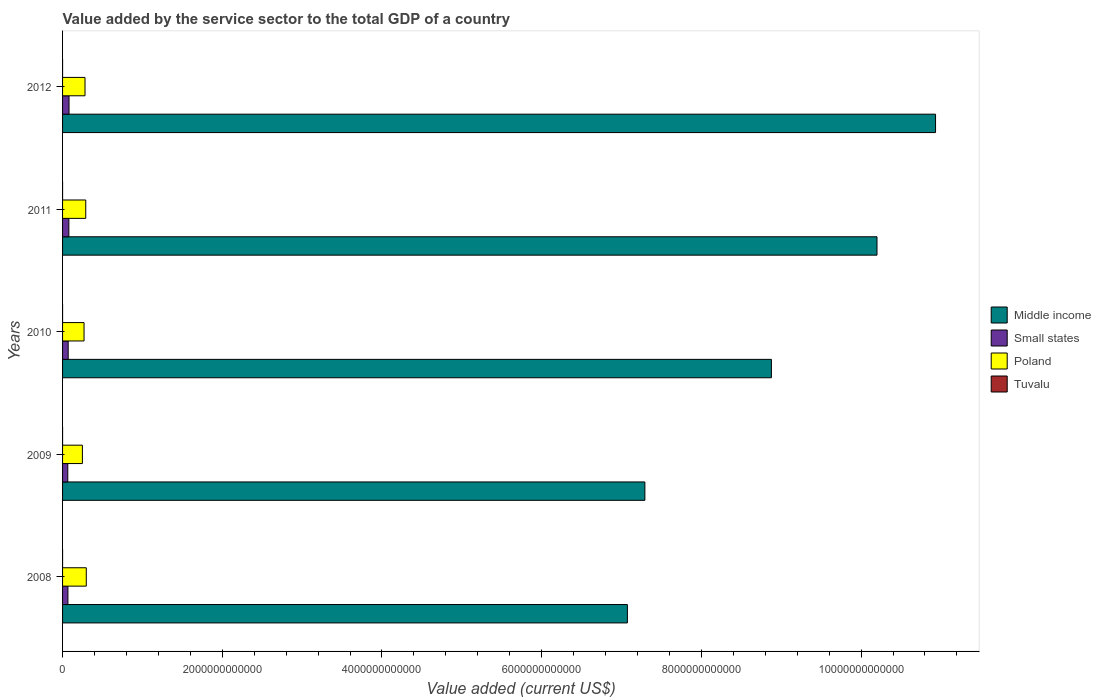How many groups of bars are there?
Your answer should be very brief. 5. Are the number of bars on each tick of the Y-axis equal?
Your answer should be very brief. Yes. How many bars are there on the 4th tick from the bottom?
Offer a terse response. 4. What is the value added by the service sector to the total GDP in Small states in 2012?
Your answer should be very brief. 8.09e+1. Across all years, what is the maximum value added by the service sector to the total GDP in Small states?
Offer a very short reply. 8.09e+1. Across all years, what is the minimum value added by the service sector to the total GDP in Middle income?
Offer a very short reply. 7.07e+12. In which year was the value added by the service sector to the total GDP in Middle income maximum?
Your answer should be very brief. 2012. What is the total value added by the service sector to the total GDP in Tuvalu in the graph?
Provide a short and direct response. 1.01e+08. What is the difference between the value added by the service sector to the total GDP in Tuvalu in 2009 and that in 2012?
Ensure brevity in your answer.  -1.04e+07. What is the difference between the value added by the service sector to the total GDP in Poland in 2010 and the value added by the service sector to the total GDP in Tuvalu in 2011?
Your answer should be very brief. 2.69e+11. What is the average value added by the service sector to the total GDP in Poland per year?
Make the answer very short. 2.77e+11. In the year 2008, what is the difference between the value added by the service sector to the total GDP in Tuvalu and value added by the service sector to the total GDP in Poland?
Your answer should be very brief. -2.97e+11. What is the ratio of the value added by the service sector to the total GDP in Small states in 2011 to that in 2012?
Make the answer very short. 0.97. Is the difference between the value added by the service sector to the total GDP in Tuvalu in 2008 and 2012 greater than the difference between the value added by the service sector to the total GDP in Poland in 2008 and 2012?
Your answer should be compact. No. What is the difference between the highest and the second highest value added by the service sector to the total GDP in Middle income?
Ensure brevity in your answer.  7.33e+11. What is the difference between the highest and the lowest value added by the service sector to the total GDP in Middle income?
Your answer should be compact. 3.86e+12. In how many years, is the value added by the service sector to the total GDP in Tuvalu greater than the average value added by the service sector to the total GDP in Tuvalu taken over all years?
Offer a very short reply. 2. Is it the case that in every year, the sum of the value added by the service sector to the total GDP in Middle income and value added by the service sector to the total GDP in Tuvalu is greater than the sum of value added by the service sector to the total GDP in Poland and value added by the service sector to the total GDP in Small states?
Keep it short and to the point. Yes. What does the 2nd bar from the bottom in 2008 represents?
Offer a terse response. Small states. Are all the bars in the graph horizontal?
Make the answer very short. Yes. What is the difference between two consecutive major ticks on the X-axis?
Offer a very short reply. 2.00e+12. Does the graph contain any zero values?
Provide a short and direct response. No. Where does the legend appear in the graph?
Your response must be concise. Center right. How are the legend labels stacked?
Make the answer very short. Vertical. What is the title of the graph?
Provide a short and direct response. Value added by the service sector to the total GDP of a country. What is the label or title of the X-axis?
Offer a very short reply. Value added (current US$). What is the label or title of the Y-axis?
Give a very brief answer. Years. What is the Value added (current US$) of Middle income in 2008?
Provide a succinct answer. 7.07e+12. What is the Value added (current US$) of Small states in 2008?
Your answer should be compact. 6.71e+1. What is the Value added (current US$) of Poland in 2008?
Make the answer very short. 2.97e+11. What is the Value added (current US$) in Tuvalu in 2008?
Provide a succinct answer. 1.70e+07. What is the Value added (current US$) in Middle income in 2009?
Provide a short and direct response. 7.29e+12. What is the Value added (current US$) of Small states in 2009?
Your answer should be compact. 6.54e+1. What is the Value added (current US$) in Poland in 2009?
Offer a very short reply. 2.48e+11. What is the Value added (current US$) of Tuvalu in 2009?
Your answer should be compact. 1.53e+07. What is the Value added (current US$) in Middle income in 2010?
Your response must be concise. 8.88e+12. What is the Value added (current US$) in Small states in 2010?
Ensure brevity in your answer.  7.04e+1. What is the Value added (current US$) in Poland in 2010?
Offer a very short reply. 2.69e+11. What is the Value added (current US$) in Tuvalu in 2010?
Provide a succinct answer. 1.94e+07. What is the Value added (current US$) in Middle income in 2011?
Your answer should be compact. 1.02e+13. What is the Value added (current US$) in Small states in 2011?
Your response must be concise. 7.88e+1. What is the Value added (current US$) of Poland in 2011?
Provide a short and direct response. 2.90e+11. What is the Value added (current US$) in Tuvalu in 2011?
Make the answer very short. 2.31e+07. What is the Value added (current US$) of Middle income in 2012?
Offer a very short reply. 1.09e+13. What is the Value added (current US$) of Small states in 2012?
Your answer should be very brief. 8.09e+1. What is the Value added (current US$) of Poland in 2012?
Your answer should be compact. 2.81e+11. What is the Value added (current US$) of Tuvalu in 2012?
Provide a succinct answer. 2.57e+07. Across all years, what is the maximum Value added (current US$) of Middle income?
Give a very brief answer. 1.09e+13. Across all years, what is the maximum Value added (current US$) of Small states?
Provide a succinct answer. 8.09e+1. Across all years, what is the maximum Value added (current US$) of Poland?
Offer a very short reply. 2.97e+11. Across all years, what is the maximum Value added (current US$) of Tuvalu?
Provide a short and direct response. 2.57e+07. Across all years, what is the minimum Value added (current US$) in Middle income?
Offer a very short reply. 7.07e+12. Across all years, what is the minimum Value added (current US$) in Small states?
Offer a terse response. 6.54e+1. Across all years, what is the minimum Value added (current US$) of Poland?
Make the answer very short. 2.48e+11. Across all years, what is the minimum Value added (current US$) of Tuvalu?
Offer a very short reply. 1.53e+07. What is the total Value added (current US$) of Middle income in the graph?
Your answer should be compact. 4.44e+13. What is the total Value added (current US$) of Small states in the graph?
Your response must be concise. 3.63e+11. What is the total Value added (current US$) of Poland in the graph?
Your answer should be compact. 1.39e+12. What is the total Value added (current US$) of Tuvalu in the graph?
Your answer should be compact. 1.01e+08. What is the difference between the Value added (current US$) in Middle income in 2008 and that in 2009?
Your answer should be compact. -2.19e+11. What is the difference between the Value added (current US$) in Small states in 2008 and that in 2009?
Offer a very short reply. 1.69e+09. What is the difference between the Value added (current US$) of Poland in 2008 and that in 2009?
Provide a short and direct response. 4.88e+1. What is the difference between the Value added (current US$) of Tuvalu in 2008 and that in 2009?
Offer a terse response. 1.70e+06. What is the difference between the Value added (current US$) of Middle income in 2008 and that in 2010?
Ensure brevity in your answer.  -1.80e+12. What is the difference between the Value added (current US$) in Small states in 2008 and that in 2010?
Your response must be concise. -3.32e+09. What is the difference between the Value added (current US$) of Poland in 2008 and that in 2010?
Provide a short and direct response. 2.80e+1. What is the difference between the Value added (current US$) in Tuvalu in 2008 and that in 2010?
Your response must be concise. -2.34e+06. What is the difference between the Value added (current US$) of Middle income in 2008 and that in 2011?
Provide a short and direct response. -3.13e+12. What is the difference between the Value added (current US$) in Small states in 2008 and that in 2011?
Keep it short and to the point. -1.17e+1. What is the difference between the Value added (current US$) in Poland in 2008 and that in 2011?
Give a very brief answer. 6.62e+09. What is the difference between the Value added (current US$) of Tuvalu in 2008 and that in 2011?
Offer a terse response. -6.05e+06. What is the difference between the Value added (current US$) in Middle income in 2008 and that in 2012?
Your answer should be very brief. -3.86e+12. What is the difference between the Value added (current US$) of Small states in 2008 and that in 2012?
Keep it short and to the point. -1.39e+1. What is the difference between the Value added (current US$) in Poland in 2008 and that in 2012?
Keep it short and to the point. 1.59e+1. What is the difference between the Value added (current US$) of Tuvalu in 2008 and that in 2012?
Provide a short and direct response. -8.68e+06. What is the difference between the Value added (current US$) of Middle income in 2009 and that in 2010?
Provide a succinct answer. -1.58e+12. What is the difference between the Value added (current US$) of Small states in 2009 and that in 2010?
Make the answer very short. -5.01e+09. What is the difference between the Value added (current US$) in Poland in 2009 and that in 2010?
Provide a succinct answer. -2.09e+1. What is the difference between the Value added (current US$) in Tuvalu in 2009 and that in 2010?
Provide a short and direct response. -4.04e+06. What is the difference between the Value added (current US$) in Middle income in 2009 and that in 2011?
Ensure brevity in your answer.  -2.91e+12. What is the difference between the Value added (current US$) in Small states in 2009 and that in 2011?
Ensure brevity in your answer.  -1.34e+1. What is the difference between the Value added (current US$) in Poland in 2009 and that in 2011?
Your answer should be very brief. -4.22e+1. What is the difference between the Value added (current US$) in Tuvalu in 2009 and that in 2011?
Make the answer very short. -7.75e+06. What is the difference between the Value added (current US$) in Middle income in 2009 and that in 2012?
Your response must be concise. -3.64e+12. What is the difference between the Value added (current US$) in Small states in 2009 and that in 2012?
Offer a terse response. -1.56e+1. What is the difference between the Value added (current US$) of Poland in 2009 and that in 2012?
Make the answer very short. -3.29e+1. What is the difference between the Value added (current US$) in Tuvalu in 2009 and that in 2012?
Your answer should be very brief. -1.04e+07. What is the difference between the Value added (current US$) in Middle income in 2010 and that in 2011?
Keep it short and to the point. -1.32e+12. What is the difference between the Value added (current US$) of Small states in 2010 and that in 2011?
Your answer should be compact. -8.39e+09. What is the difference between the Value added (current US$) of Poland in 2010 and that in 2011?
Make the answer very short. -2.13e+1. What is the difference between the Value added (current US$) in Tuvalu in 2010 and that in 2011?
Your response must be concise. -3.71e+06. What is the difference between the Value added (current US$) of Middle income in 2010 and that in 2012?
Ensure brevity in your answer.  -2.06e+12. What is the difference between the Value added (current US$) of Small states in 2010 and that in 2012?
Give a very brief answer. -1.06e+1. What is the difference between the Value added (current US$) of Poland in 2010 and that in 2012?
Give a very brief answer. -1.21e+1. What is the difference between the Value added (current US$) of Tuvalu in 2010 and that in 2012?
Offer a terse response. -6.33e+06. What is the difference between the Value added (current US$) of Middle income in 2011 and that in 2012?
Offer a terse response. -7.33e+11. What is the difference between the Value added (current US$) in Small states in 2011 and that in 2012?
Your response must be concise. -2.16e+09. What is the difference between the Value added (current US$) in Poland in 2011 and that in 2012?
Your answer should be very brief. 9.29e+09. What is the difference between the Value added (current US$) of Tuvalu in 2011 and that in 2012?
Give a very brief answer. -2.62e+06. What is the difference between the Value added (current US$) of Middle income in 2008 and the Value added (current US$) of Small states in 2009?
Ensure brevity in your answer.  7.01e+12. What is the difference between the Value added (current US$) in Middle income in 2008 and the Value added (current US$) in Poland in 2009?
Provide a short and direct response. 6.83e+12. What is the difference between the Value added (current US$) in Middle income in 2008 and the Value added (current US$) in Tuvalu in 2009?
Offer a terse response. 7.07e+12. What is the difference between the Value added (current US$) in Small states in 2008 and the Value added (current US$) in Poland in 2009?
Provide a short and direct response. -1.81e+11. What is the difference between the Value added (current US$) of Small states in 2008 and the Value added (current US$) of Tuvalu in 2009?
Provide a succinct answer. 6.71e+1. What is the difference between the Value added (current US$) in Poland in 2008 and the Value added (current US$) in Tuvalu in 2009?
Provide a short and direct response. 2.97e+11. What is the difference between the Value added (current US$) in Middle income in 2008 and the Value added (current US$) in Small states in 2010?
Provide a short and direct response. 7.00e+12. What is the difference between the Value added (current US$) of Middle income in 2008 and the Value added (current US$) of Poland in 2010?
Offer a terse response. 6.80e+12. What is the difference between the Value added (current US$) in Middle income in 2008 and the Value added (current US$) in Tuvalu in 2010?
Your answer should be compact. 7.07e+12. What is the difference between the Value added (current US$) of Small states in 2008 and the Value added (current US$) of Poland in 2010?
Provide a succinct answer. -2.02e+11. What is the difference between the Value added (current US$) of Small states in 2008 and the Value added (current US$) of Tuvalu in 2010?
Provide a succinct answer. 6.70e+1. What is the difference between the Value added (current US$) of Poland in 2008 and the Value added (current US$) of Tuvalu in 2010?
Offer a terse response. 2.97e+11. What is the difference between the Value added (current US$) of Middle income in 2008 and the Value added (current US$) of Small states in 2011?
Give a very brief answer. 6.99e+12. What is the difference between the Value added (current US$) in Middle income in 2008 and the Value added (current US$) in Poland in 2011?
Ensure brevity in your answer.  6.78e+12. What is the difference between the Value added (current US$) of Middle income in 2008 and the Value added (current US$) of Tuvalu in 2011?
Offer a very short reply. 7.07e+12. What is the difference between the Value added (current US$) in Small states in 2008 and the Value added (current US$) in Poland in 2011?
Ensure brevity in your answer.  -2.23e+11. What is the difference between the Value added (current US$) in Small states in 2008 and the Value added (current US$) in Tuvalu in 2011?
Provide a short and direct response. 6.70e+1. What is the difference between the Value added (current US$) in Poland in 2008 and the Value added (current US$) in Tuvalu in 2011?
Ensure brevity in your answer.  2.97e+11. What is the difference between the Value added (current US$) in Middle income in 2008 and the Value added (current US$) in Small states in 2012?
Provide a succinct answer. 6.99e+12. What is the difference between the Value added (current US$) in Middle income in 2008 and the Value added (current US$) in Poland in 2012?
Give a very brief answer. 6.79e+12. What is the difference between the Value added (current US$) in Middle income in 2008 and the Value added (current US$) in Tuvalu in 2012?
Provide a succinct answer. 7.07e+12. What is the difference between the Value added (current US$) in Small states in 2008 and the Value added (current US$) in Poland in 2012?
Keep it short and to the point. -2.14e+11. What is the difference between the Value added (current US$) of Small states in 2008 and the Value added (current US$) of Tuvalu in 2012?
Ensure brevity in your answer.  6.70e+1. What is the difference between the Value added (current US$) of Poland in 2008 and the Value added (current US$) of Tuvalu in 2012?
Keep it short and to the point. 2.97e+11. What is the difference between the Value added (current US$) of Middle income in 2009 and the Value added (current US$) of Small states in 2010?
Make the answer very short. 7.22e+12. What is the difference between the Value added (current US$) in Middle income in 2009 and the Value added (current US$) in Poland in 2010?
Provide a short and direct response. 7.02e+12. What is the difference between the Value added (current US$) of Middle income in 2009 and the Value added (current US$) of Tuvalu in 2010?
Give a very brief answer. 7.29e+12. What is the difference between the Value added (current US$) in Small states in 2009 and the Value added (current US$) in Poland in 2010?
Offer a terse response. -2.04e+11. What is the difference between the Value added (current US$) of Small states in 2009 and the Value added (current US$) of Tuvalu in 2010?
Provide a succinct answer. 6.54e+1. What is the difference between the Value added (current US$) in Poland in 2009 and the Value added (current US$) in Tuvalu in 2010?
Your answer should be very brief. 2.48e+11. What is the difference between the Value added (current US$) in Middle income in 2009 and the Value added (current US$) in Small states in 2011?
Your answer should be compact. 7.21e+12. What is the difference between the Value added (current US$) of Middle income in 2009 and the Value added (current US$) of Poland in 2011?
Your response must be concise. 7.00e+12. What is the difference between the Value added (current US$) in Middle income in 2009 and the Value added (current US$) in Tuvalu in 2011?
Your answer should be very brief. 7.29e+12. What is the difference between the Value added (current US$) in Small states in 2009 and the Value added (current US$) in Poland in 2011?
Your answer should be very brief. -2.25e+11. What is the difference between the Value added (current US$) of Small states in 2009 and the Value added (current US$) of Tuvalu in 2011?
Your answer should be compact. 6.54e+1. What is the difference between the Value added (current US$) of Poland in 2009 and the Value added (current US$) of Tuvalu in 2011?
Your answer should be compact. 2.48e+11. What is the difference between the Value added (current US$) in Middle income in 2009 and the Value added (current US$) in Small states in 2012?
Offer a very short reply. 7.21e+12. What is the difference between the Value added (current US$) of Middle income in 2009 and the Value added (current US$) of Poland in 2012?
Give a very brief answer. 7.01e+12. What is the difference between the Value added (current US$) of Middle income in 2009 and the Value added (current US$) of Tuvalu in 2012?
Your answer should be compact. 7.29e+12. What is the difference between the Value added (current US$) in Small states in 2009 and the Value added (current US$) in Poland in 2012?
Provide a succinct answer. -2.16e+11. What is the difference between the Value added (current US$) in Small states in 2009 and the Value added (current US$) in Tuvalu in 2012?
Your response must be concise. 6.54e+1. What is the difference between the Value added (current US$) in Poland in 2009 and the Value added (current US$) in Tuvalu in 2012?
Offer a terse response. 2.48e+11. What is the difference between the Value added (current US$) in Middle income in 2010 and the Value added (current US$) in Small states in 2011?
Provide a short and direct response. 8.80e+12. What is the difference between the Value added (current US$) in Middle income in 2010 and the Value added (current US$) in Poland in 2011?
Offer a very short reply. 8.59e+12. What is the difference between the Value added (current US$) of Middle income in 2010 and the Value added (current US$) of Tuvalu in 2011?
Your answer should be very brief. 8.88e+12. What is the difference between the Value added (current US$) in Small states in 2010 and the Value added (current US$) in Poland in 2011?
Keep it short and to the point. -2.20e+11. What is the difference between the Value added (current US$) in Small states in 2010 and the Value added (current US$) in Tuvalu in 2011?
Provide a short and direct response. 7.04e+1. What is the difference between the Value added (current US$) of Poland in 2010 and the Value added (current US$) of Tuvalu in 2011?
Provide a succinct answer. 2.69e+11. What is the difference between the Value added (current US$) in Middle income in 2010 and the Value added (current US$) in Small states in 2012?
Offer a terse response. 8.80e+12. What is the difference between the Value added (current US$) in Middle income in 2010 and the Value added (current US$) in Poland in 2012?
Offer a terse response. 8.60e+12. What is the difference between the Value added (current US$) in Middle income in 2010 and the Value added (current US$) in Tuvalu in 2012?
Ensure brevity in your answer.  8.88e+12. What is the difference between the Value added (current US$) of Small states in 2010 and the Value added (current US$) of Poland in 2012?
Provide a short and direct response. -2.11e+11. What is the difference between the Value added (current US$) of Small states in 2010 and the Value added (current US$) of Tuvalu in 2012?
Your answer should be very brief. 7.04e+1. What is the difference between the Value added (current US$) in Poland in 2010 and the Value added (current US$) in Tuvalu in 2012?
Offer a terse response. 2.69e+11. What is the difference between the Value added (current US$) in Middle income in 2011 and the Value added (current US$) in Small states in 2012?
Provide a short and direct response. 1.01e+13. What is the difference between the Value added (current US$) in Middle income in 2011 and the Value added (current US$) in Poland in 2012?
Give a very brief answer. 9.92e+12. What is the difference between the Value added (current US$) of Middle income in 2011 and the Value added (current US$) of Tuvalu in 2012?
Provide a short and direct response. 1.02e+13. What is the difference between the Value added (current US$) of Small states in 2011 and the Value added (current US$) of Poland in 2012?
Give a very brief answer. -2.02e+11. What is the difference between the Value added (current US$) in Small states in 2011 and the Value added (current US$) in Tuvalu in 2012?
Offer a very short reply. 7.88e+1. What is the difference between the Value added (current US$) of Poland in 2011 and the Value added (current US$) of Tuvalu in 2012?
Your answer should be compact. 2.90e+11. What is the average Value added (current US$) of Middle income per year?
Offer a terse response. 8.88e+12. What is the average Value added (current US$) in Small states per year?
Provide a succinct answer. 7.25e+1. What is the average Value added (current US$) of Poland per year?
Provide a short and direct response. 2.77e+11. What is the average Value added (current US$) in Tuvalu per year?
Your answer should be very brief. 2.01e+07. In the year 2008, what is the difference between the Value added (current US$) of Middle income and Value added (current US$) of Small states?
Give a very brief answer. 7.01e+12. In the year 2008, what is the difference between the Value added (current US$) in Middle income and Value added (current US$) in Poland?
Ensure brevity in your answer.  6.78e+12. In the year 2008, what is the difference between the Value added (current US$) in Middle income and Value added (current US$) in Tuvalu?
Your answer should be very brief. 7.07e+12. In the year 2008, what is the difference between the Value added (current US$) in Small states and Value added (current US$) in Poland?
Keep it short and to the point. -2.30e+11. In the year 2008, what is the difference between the Value added (current US$) of Small states and Value added (current US$) of Tuvalu?
Keep it short and to the point. 6.71e+1. In the year 2008, what is the difference between the Value added (current US$) of Poland and Value added (current US$) of Tuvalu?
Provide a short and direct response. 2.97e+11. In the year 2009, what is the difference between the Value added (current US$) in Middle income and Value added (current US$) in Small states?
Provide a short and direct response. 7.23e+12. In the year 2009, what is the difference between the Value added (current US$) in Middle income and Value added (current US$) in Poland?
Make the answer very short. 7.04e+12. In the year 2009, what is the difference between the Value added (current US$) of Middle income and Value added (current US$) of Tuvalu?
Make the answer very short. 7.29e+12. In the year 2009, what is the difference between the Value added (current US$) in Small states and Value added (current US$) in Poland?
Your answer should be very brief. -1.83e+11. In the year 2009, what is the difference between the Value added (current US$) in Small states and Value added (current US$) in Tuvalu?
Your answer should be very brief. 6.54e+1. In the year 2009, what is the difference between the Value added (current US$) in Poland and Value added (current US$) in Tuvalu?
Give a very brief answer. 2.48e+11. In the year 2010, what is the difference between the Value added (current US$) in Middle income and Value added (current US$) in Small states?
Provide a succinct answer. 8.81e+12. In the year 2010, what is the difference between the Value added (current US$) in Middle income and Value added (current US$) in Poland?
Offer a very short reply. 8.61e+12. In the year 2010, what is the difference between the Value added (current US$) of Middle income and Value added (current US$) of Tuvalu?
Make the answer very short. 8.88e+12. In the year 2010, what is the difference between the Value added (current US$) in Small states and Value added (current US$) in Poland?
Your response must be concise. -1.99e+11. In the year 2010, what is the difference between the Value added (current US$) of Small states and Value added (current US$) of Tuvalu?
Provide a succinct answer. 7.04e+1. In the year 2010, what is the difference between the Value added (current US$) of Poland and Value added (current US$) of Tuvalu?
Make the answer very short. 2.69e+11. In the year 2011, what is the difference between the Value added (current US$) of Middle income and Value added (current US$) of Small states?
Provide a short and direct response. 1.01e+13. In the year 2011, what is the difference between the Value added (current US$) of Middle income and Value added (current US$) of Poland?
Your answer should be compact. 9.91e+12. In the year 2011, what is the difference between the Value added (current US$) in Middle income and Value added (current US$) in Tuvalu?
Provide a succinct answer. 1.02e+13. In the year 2011, what is the difference between the Value added (current US$) in Small states and Value added (current US$) in Poland?
Your answer should be very brief. -2.12e+11. In the year 2011, what is the difference between the Value added (current US$) of Small states and Value added (current US$) of Tuvalu?
Your answer should be compact. 7.88e+1. In the year 2011, what is the difference between the Value added (current US$) of Poland and Value added (current US$) of Tuvalu?
Make the answer very short. 2.90e+11. In the year 2012, what is the difference between the Value added (current US$) of Middle income and Value added (current US$) of Small states?
Your response must be concise. 1.09e+13. In the year 2012, what is the difference between the Value added (current US$) of Middle income and Value added (current US$) of Poland?
Offer a very short reply. 1.07e+13. In the year 2012, what is the difference between the Value added (current US$) of Middle income and Value added (current US$) of Tuvalu?
Offer a terse response. 1.09e+13. In the year 2012, what is the difference between the Value added (current US$) in Small states and Value added (current US$) in Poland?
Give a very brief answer. -2.00e+11. In the year 2012, what is the difference between the Value added (current US$) in Small states and Value added (current US$) in Tuvalu?
Make the answer very short. 8.09e+1. In the year 2012, what is the difference between the Value added (current US$) in Poland and Value added (current US$) in Tuvalu?
Ensure brevity in your answer.  2.81e+11. What is the ratio of the Value added (current US$) in Middle income in 2008 to that in 2009?
Your answer should be compact. 0.97. What is the ratio of the Value added (current US$) of Small states in 2008 to that in 2009?
Ensure brevity in your answer.  1.03. What is the ratio of the Value added (current US$) in Poland in 2008 to that in 2009?
Your answer should be very brief. 1.2. What is the ratio of the Value added (current US$) of Tuvalu in 2008 to that in 2009?
Provide a short and direct response. 1.11. What is the ratio of the Value added (current US$) in Middle income in 2008 to that in 2010?
Ensure brevity in your answer.  0.8. What is the ratio of the Value added (current US$) of Small states in 2008 to that in 2010?
Give a very brief answer. 0.95. What is the ratio of the Value added (current US$) in Poland in 2008 to that in 2010?
Provide a succinct answer. 1.1. What is the ratio of the Value added (current US$) of Tuvalu in 2008 to that in 2010?
Your response must be concise. 0.88. What is the ratio of the Value added (current US$) in Middle income in 2008 to that in 2011?
Ensure brevity in your answer.  0.69. What is the ratio of the Value added (current US$) of Small states in 2008 to that in 2011?
Your answer should be very brief. 0.85. What is the ratio of the Value added (current US$) in Poland in 2008 to that in 2011?
Provide a short and direct response. 1.02. What is the ratio of the Value added (current US$) in Tuvalu in 2008 to that in 2011?
Keep it short and to the point. 0.74. What is the ratio of the Value added (current US$) in Middle income in 2008 to that in 2012?
Offer a very short reply. 0.65. What is the ratio of the Value added (current US$) in Small states in 2008 to that in 2012?
Your answer should be very brief. 0.83. What is the ratio of the Value added (current US$) in Poland in 2008 to that in 2012?
Keep it short and to the point. 1.06. What is the ratio of the Value added (current US$) in Tuvalu in 2008 to that in 2012?
Make the answer very short. 0.66. What is the ratio of the Value added (current US$) of Middle income in 2009 to that in 2010?
Give a very brief answer. 0.82. What is the ratio of the Value added (current US$) of Small states in 2009 to that in 2010?
Offer a very short reply. 0.93. What is the ratio of the Value added (current US$) of Poland in 2009 to that in 2010?
Provide a succinct answer. 0.92. What is the ratio of the Value added (current US$) of Tuvalu in 2009 to that in 2010?
Provide a succinct answer. 0.79. What is the ratio of the Value added (current US$) of Middle income in 2009 to that in 2011?
Make the answer very short. 0.71. What is the ratio of the Value added (current US$) in Small states in 2009 to that in 2011?
Offer a very short reply. 0.83. What is the ratio of the Value added (current US$) in Poland in 2009 to that in 2011?
Make the answer very short. 0.85. What is the ratio of the Value added (current US$) in Tuvalu in 2009 to that in 2011?
Provide a short and direct response. 0.66. What is the ratio of the Value added (current US$) of Middle income in 2009 to that in 2012?
Offer a very short reply. 0.67. What is the ratio of the Value added (current US$) of Small states in 2009 to that in 2012?
Your answer should be very brief. 0.81. What is the ratio of the Value added (current US$) of Poland in 2009 to that in 2012?
Make the answer very short. 0.88. What is the ratio of the Value added (current US$) in Tuvalu in 2009 to that in 2012?
Your response must be concise. 0.6. What is the ratio of the Value added (current US$) of Middle income in 2010 to that in 2011?
Offer a terse response. 0.87. What is the ratio of the Value added (current US$) of Small states in 2010 to that in 2011?
Offer a very short reply. 0.89. What is the ratio of the Value added (current US$) in Poland in 2010 to that in 2011?
Your answer should be very brief. 0.93. What is the ratio of the Value added (current US$) in Tuvalu in 2010 to that in 2011?
Give a very brief answer. 0.84. What is the ratio of the Value added (current US$) of Middle income in 2010 to that in 2012?
Provide a short and direct response. 0.81. What is the ratio of the Value added (current US$) of Small states in 2010 to that in 2012?
Keep it short and to the point. 0.87. What is the ratio of the Value added (current US$) in Poland in 2010 to that in 2012?
Give a very brief answer. 0.96. What is the ratio of the Value added (current US$) of Tuvalu in 2010 to that in 2012?
Make the answer very short. 0.75. What is the ratio of the Value added (current US$) of Middle income in 2011 to that in 2012?
Keep it short and to the point. 0.93. What is the ratio of the Value added (current US$) of Small states in 2011 to that in 2012?
Your response must be concise. 0.97. What is the ratio of the Value added (current US$) of Poland in 2011 to that in 2012?
Provide a short and direct response. 1.03. What is the ratio of the Value added (current US$) of Tuvalu in 2011 to that in 2012?
Keep it short and to the point. 0.9. What is the difference between the highest and the second highest Value added (current US$) in Middle income?
Your response must be concise. 7.33e+11. What is the difference between the highest and the second highest Value added (current US$) of Small states?
Ensure brevity in your answer.  2.16e+09. What is the difference between the highest and the second highest Value added (current US$) in Poland?
Provide a short and direct response. 6.62e+09. What is the difference between the highest and the second highest Value added (current US$) in Tuvalu?
Offer a terse response. 2.62e+06. What is the difference between the highest and the lowest Value added (current US$) of Middle income?
Provide a succinct answer. 3.86e+12. What is the difference between the highest and the lowest Value added (current US$) in Small states?
Offer a very short reply. 1.56e+1. What is the difference between the highest and the lowest Value added (current US$) of Poland?
Keep it short and to the point. 4.88e+1. What is the difference between the highest and the lowest Value added (current US$) in Tuvalu?
Your answer should be very brief. 1.04e+07. 